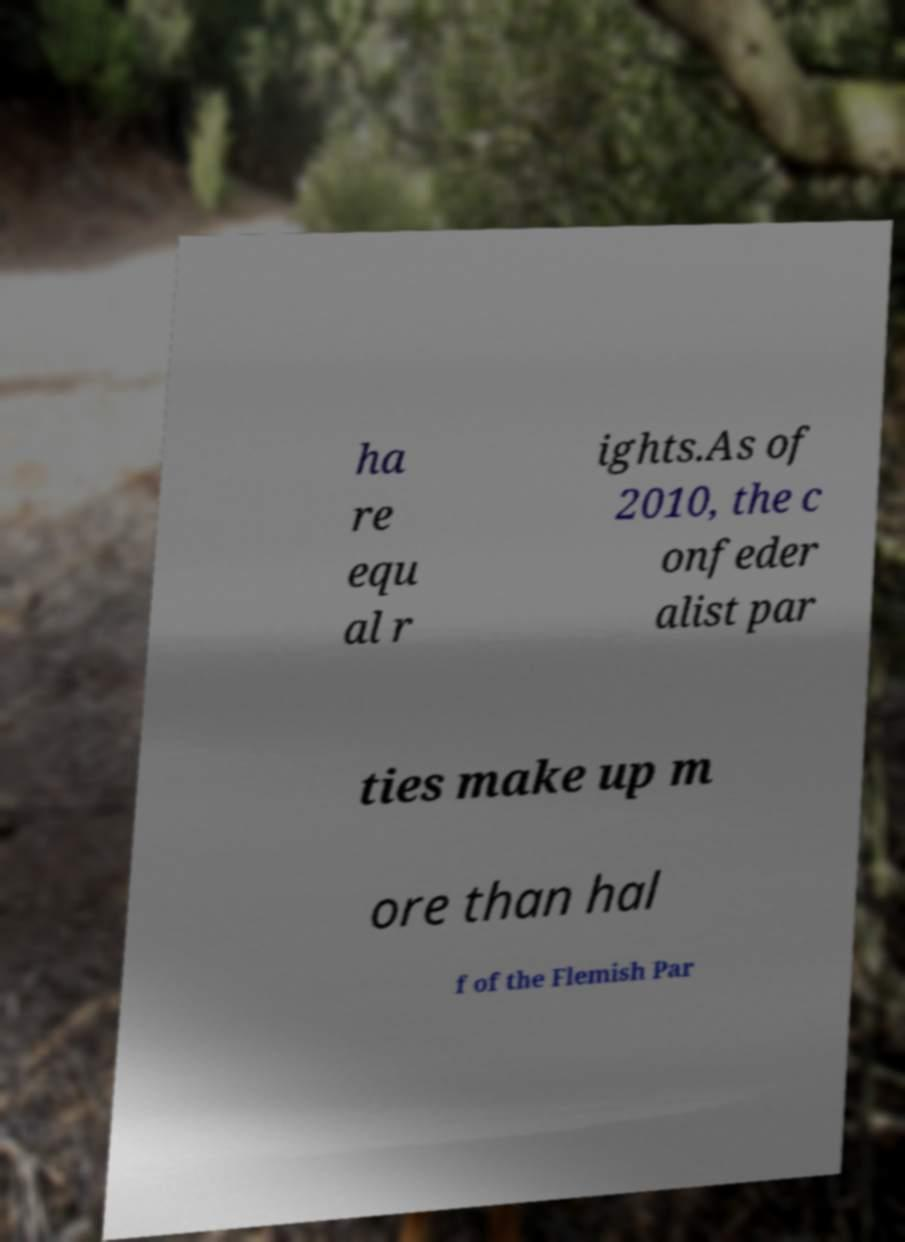What messages or text are displayed in this image? I need them in a readable, typed format. ha re equ al r ights.As of 2010, the c onfeder alist par ties make up m ore than hal f of the Flemish Par 